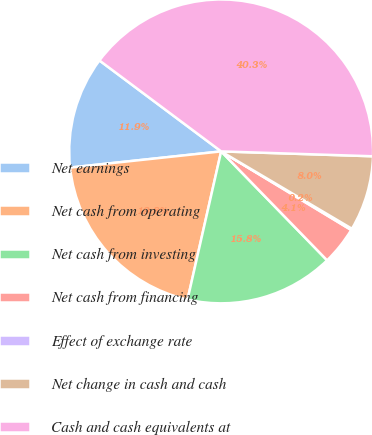Convert chart. <chart><loc_0><loc_0><loc_500><loc_500><pie_chart><fcel>Net earnings<fcel>Net cash from operating<fcel>Net cash from investing<fcel>Net cash from financing<fcel>Effect of exchange rate<fcel>Net change in cash and cash<fcel>Cash and cash equivalents at<nl><fcel>11.91%<fcel>19.75%<fcel>15.83%<fcel>4.07%<fcel>0.15%<fcel>7.99%<fcel>40.3%<nl></chart> 